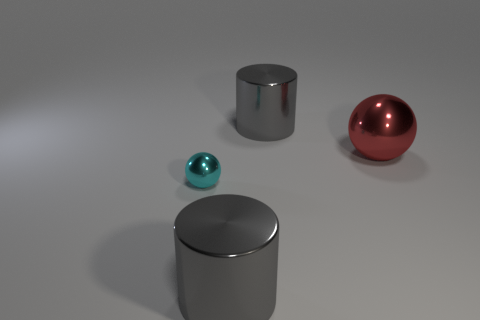Does the big gray cylinder in front of the cyan metal object have the same material as the gray cylinder behind the cyan metal thing?
Ensure brevity in your answer.  Yes. What number of gray things are the same shape as the small cyan object?
Make the answer very short. 0. How many things are big red objects or large objects that are behind the tiny ball?
Provide a succinct answer. 2. There is another thing that is the same shape as the small cyan object; what material is it?
Offer a terse response. Metal. The small metallic thing on the left side of the metallic cylinder that is behind the red object is what color?
Your answer should be compact. Cyan. How many matte objects are cylinders or red objects?
Your response must be concise. 0. What number of small objects are cyan balls or metal blocks?
Provide a succinct answer. 1. The red thing is what size?
Ensure brevity in your answer.  Large. Is the number of red metal objects that are to the right of the cyan shiny thing greater than the number of large blue rubber balls?
Your answer should be very brief. Yes. Are there an equal number of objects that are to the left of the red shiny thing and large gray metallic objects that are left of the small thing?
Offer a very short reply. No. 